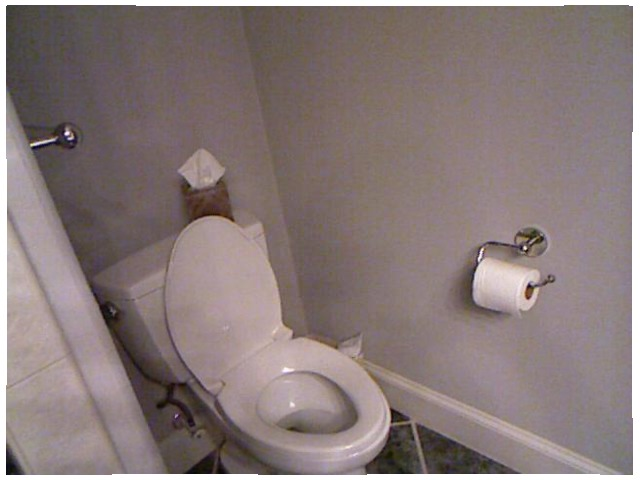<image>
Is the toilet paper in front of the wall? Yes. The toilet paper is positioned in front of the wall, appearing closer to the camera viewpoint. Where is the kleenex in relation to the toilet? Is it on the toilet? Yes. Looking at the image, I can see the kleenex is positioned on top of the toilet, with the toilet providing support. 